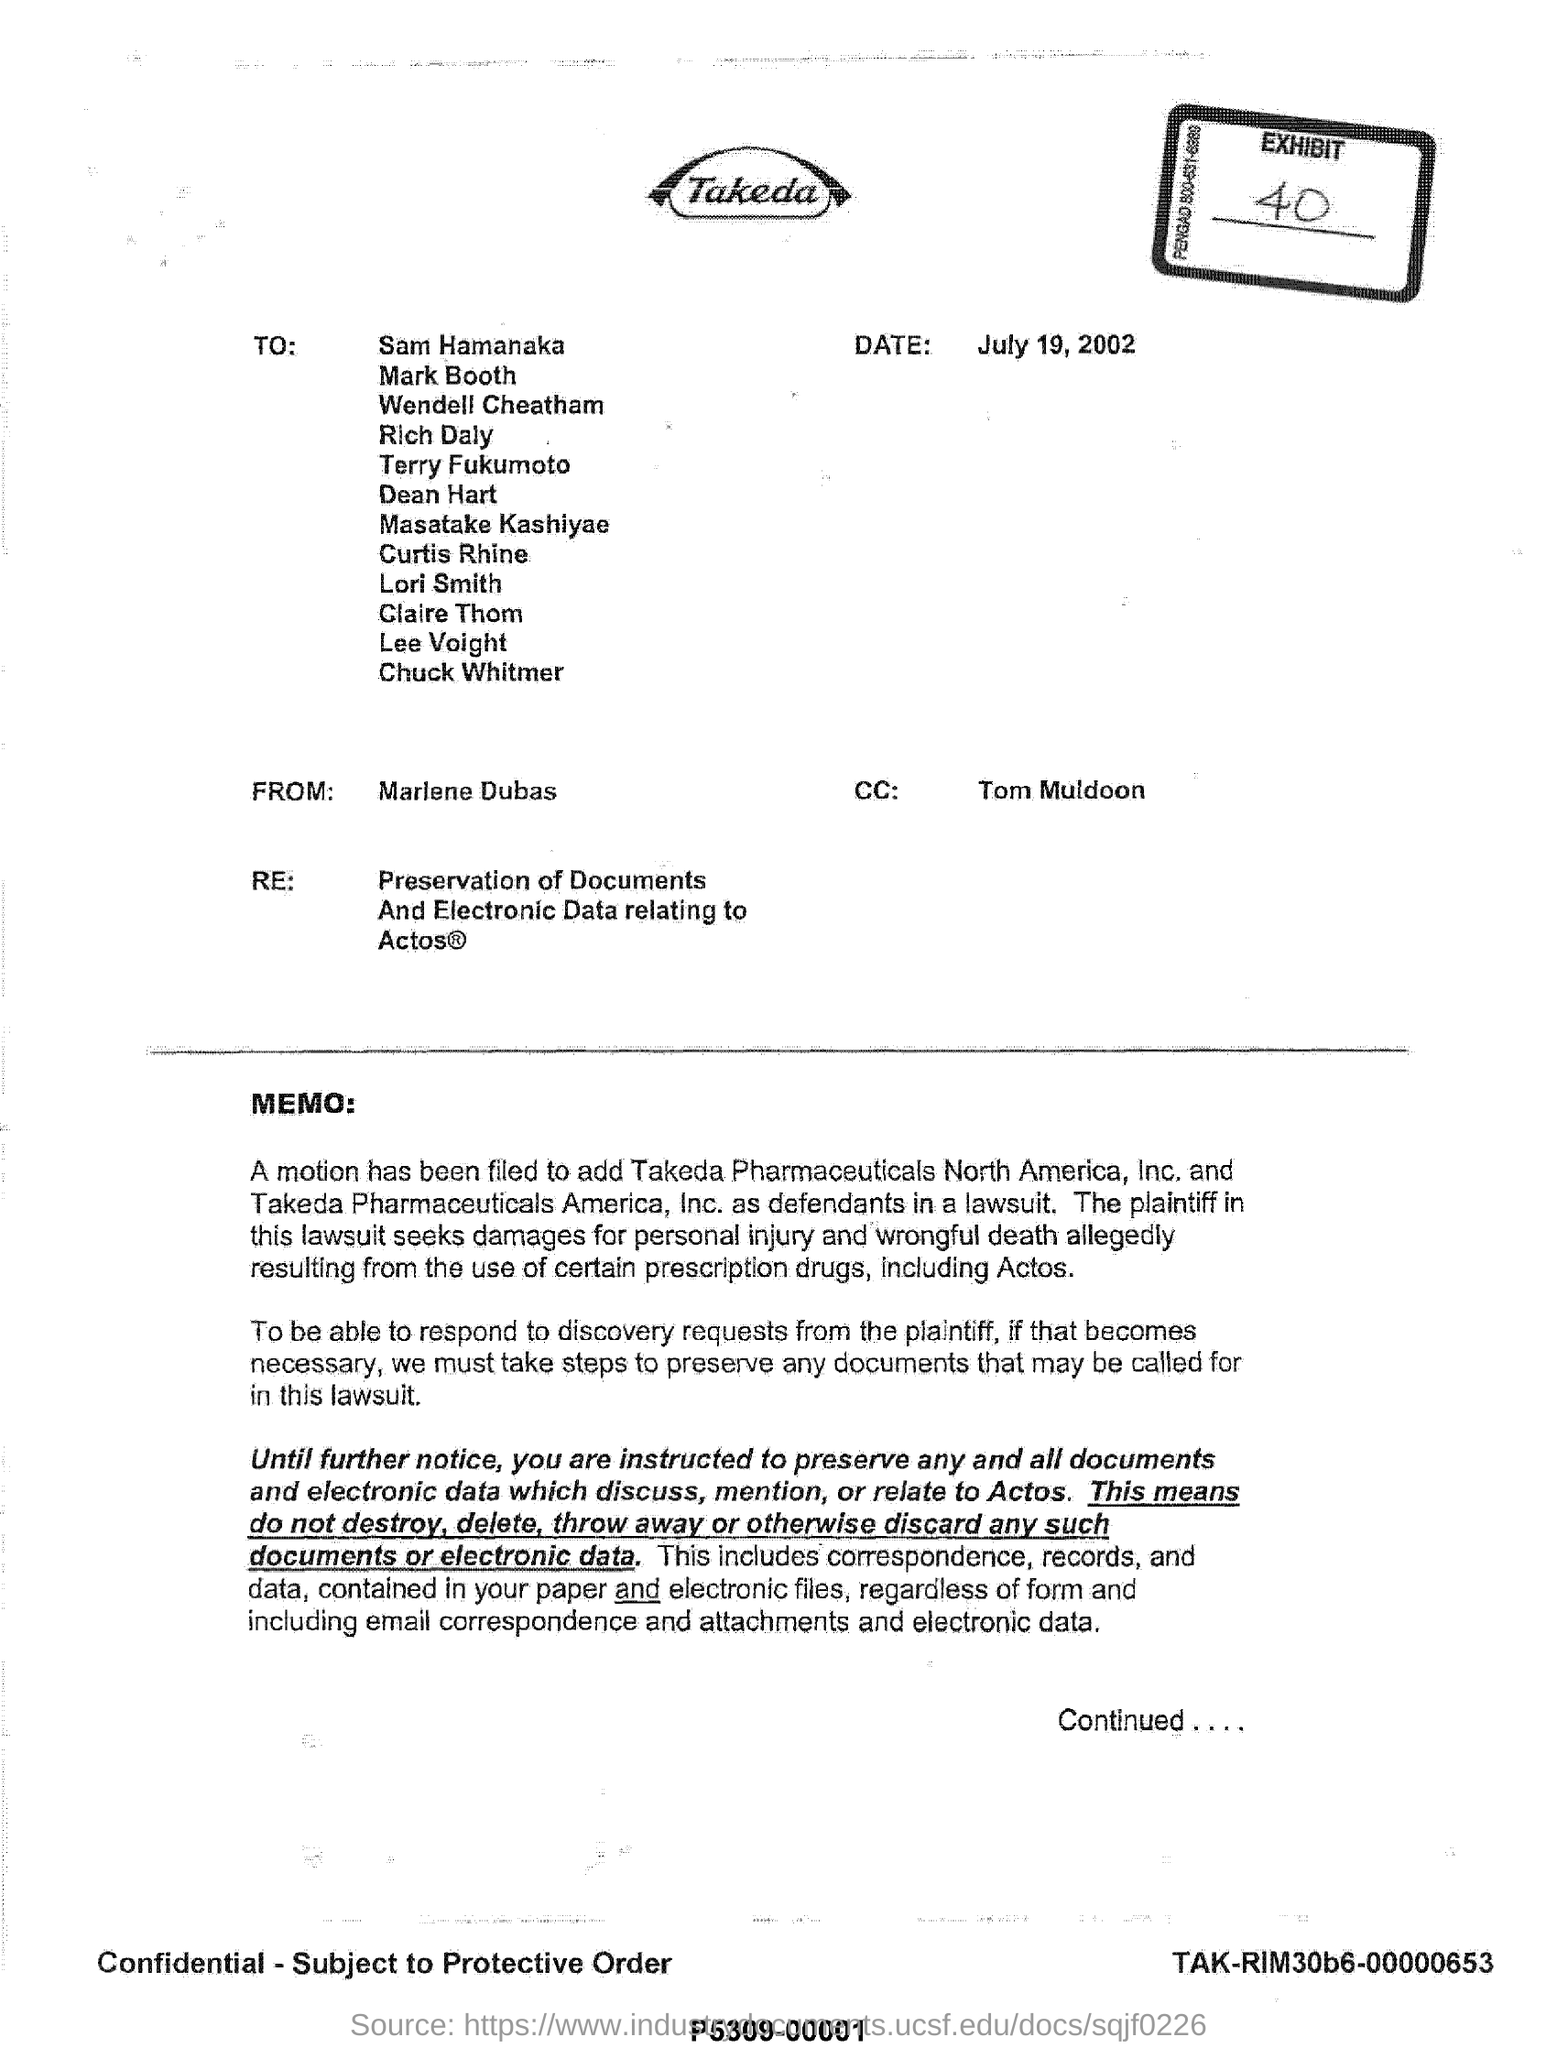Who is writing this letter?
Your response must be concise. Marlene dubas. Who is in the cc?
Ensure brevity in your answer.  Tom muldoon. Which all  compaies are added as defendants in a lawsuit?
Provide a succinct answer. Takeda Pharmaceuticals North America, Inc. and Takeda Pharmaceuticals America, Inc. What is 're' in the letter?
Offer a very short reply. Preservation of documents and electronic data relating to actos. 